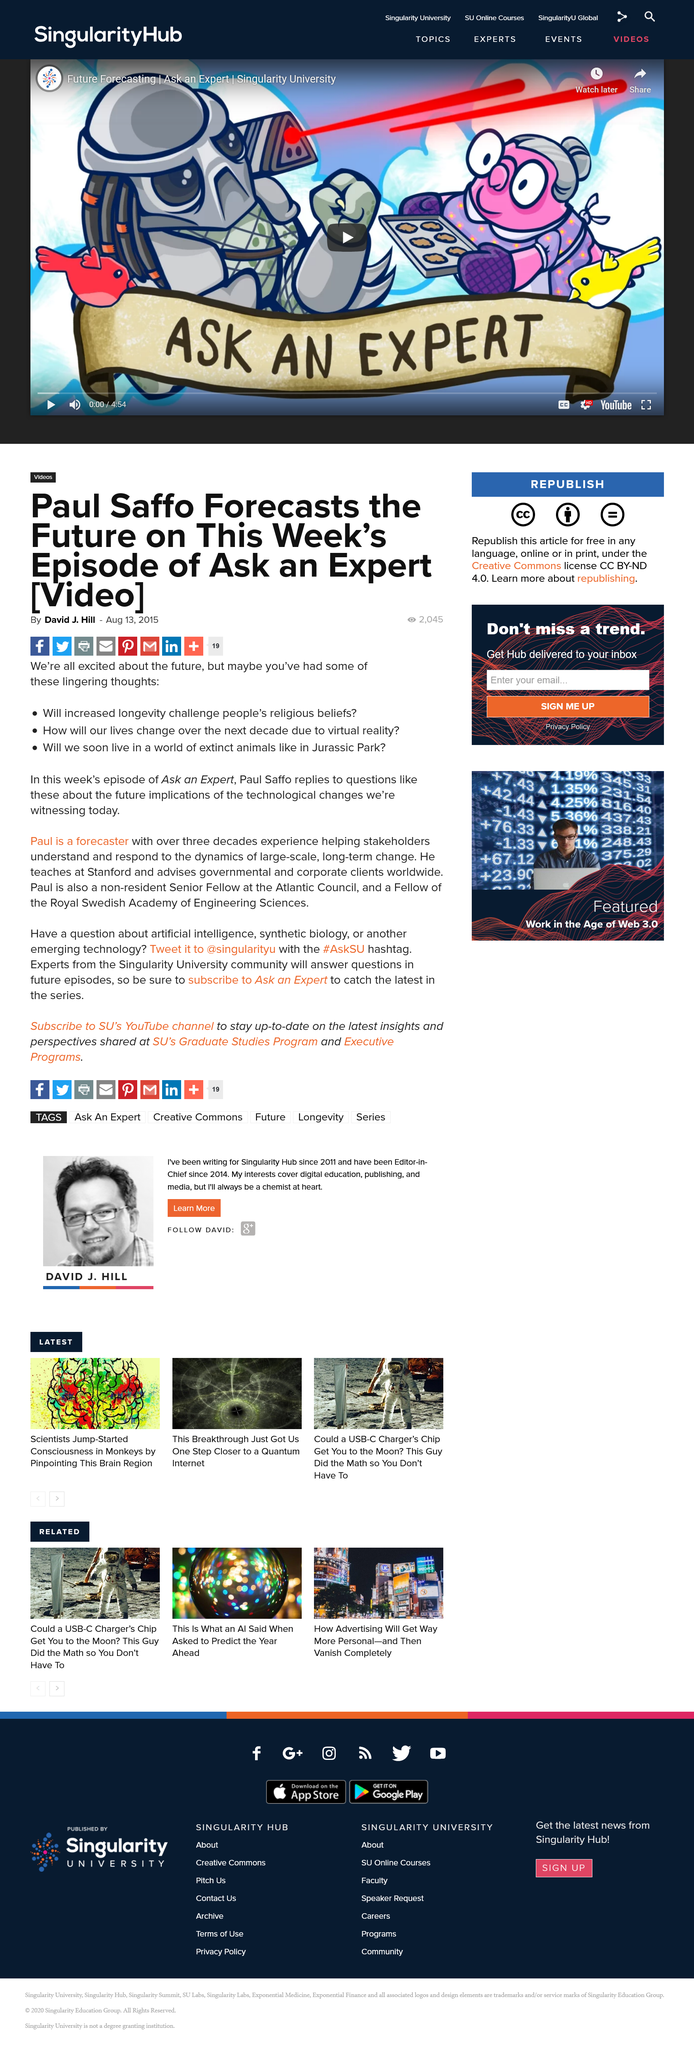Point out several critical features in this image. Paul has been a forecaster for three entire decades, amassing a wealth of experience and expertise in the field. Saffo teaches at Stanford University. Paul is not a resident Senior Fellow at the Atlantic Council. 